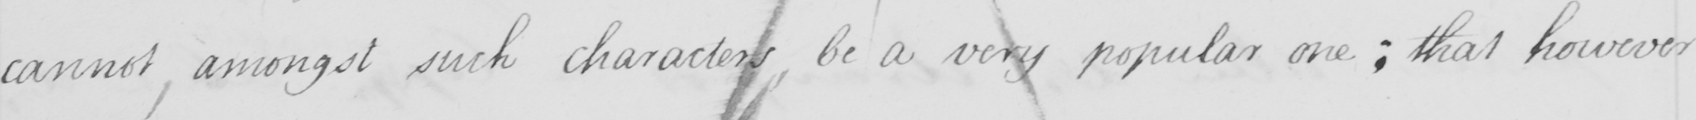Can you tell me what this handwritten text says? cannot, amongst such character be a very popular one; that however 